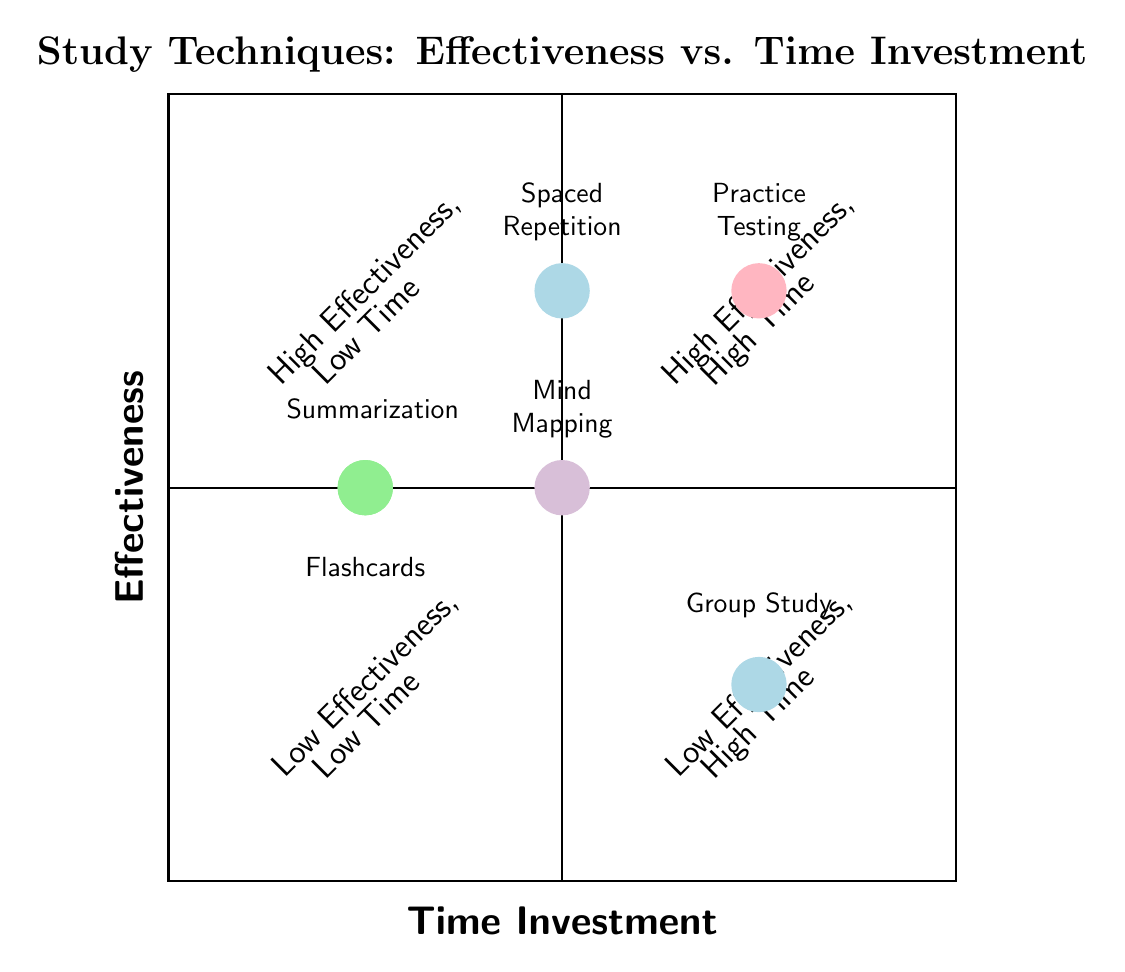What technique has high effectiveness and medium time investment? From the diagram, we can locate techniques that fit the criteria of high effectiveness and medium time investment in the top left quadrant. There, we can identify "Spaced Repetition" which is positioned at the intersection of high effectiveness and medium time investment.
Answer: Spaced Repetition Which technique is associated with high time investment but low effectiveness? Looking at the bottom right quadrant of the diagram, we find "Group Study." It is clearly marked in the low effectiveness and high time investment area, confirming its classification.
Answer: Group Study How many techniques are categorized under medium effectiveness? By checking the elements in the diagram, we can see that "Summarization," "Mind Mapping," and "Flashcards" are categorized as medium effectiveness. That gives us a total of three techniques.
Answer: 3 Which study technique requires the least time investment? The diagram indicates that both "Summarization" and "Flashcards" fall in the low time investment category. A review shows they occupy the same space in the respective quadrant for low time investment.
Answer: Summarization and Flashcards Where can Practice Testing be found in relation to effectiveness and time investment? Analyzing the position of "Practice Testing," it is located in the top right quadrant, indicating it has high effectiveness while also requiring high time investment. This positioning shows a correlation between effectiveness and the amount of time dedicated.
Answer: Top right quadrant What common characteristic do Spaced Repetition and Practice Testing share? Both "Spaced Repetition" and "Practice Testing" are located in the record showing high effectiveness, indicating that they both are viewed as very effective study techniques.
Answer: High effectiveness How does Mind Mapping compare in effectiveness to Practice Testing? "Mind Mapping" is situated in the medium effectiveness category, beneath the category of "Practice Testing," which is in the high effectiveness area. This indicates that "Mind Mapping" is perceived as less effective compared to "Practice Testing."
Answer: Less effective What type of relationship exists between time investment and effectiveness for Group Study and Flashcards? "Group Study" is categorized as low effectiveness with high time investment, while "Flashcards" are medium effectiveness with low time investment. This shows that higher time invested does not always equate to higher effectiveness, reflecting an inverse relationship between the two for these techniques.
Answer: Inverse relationship 